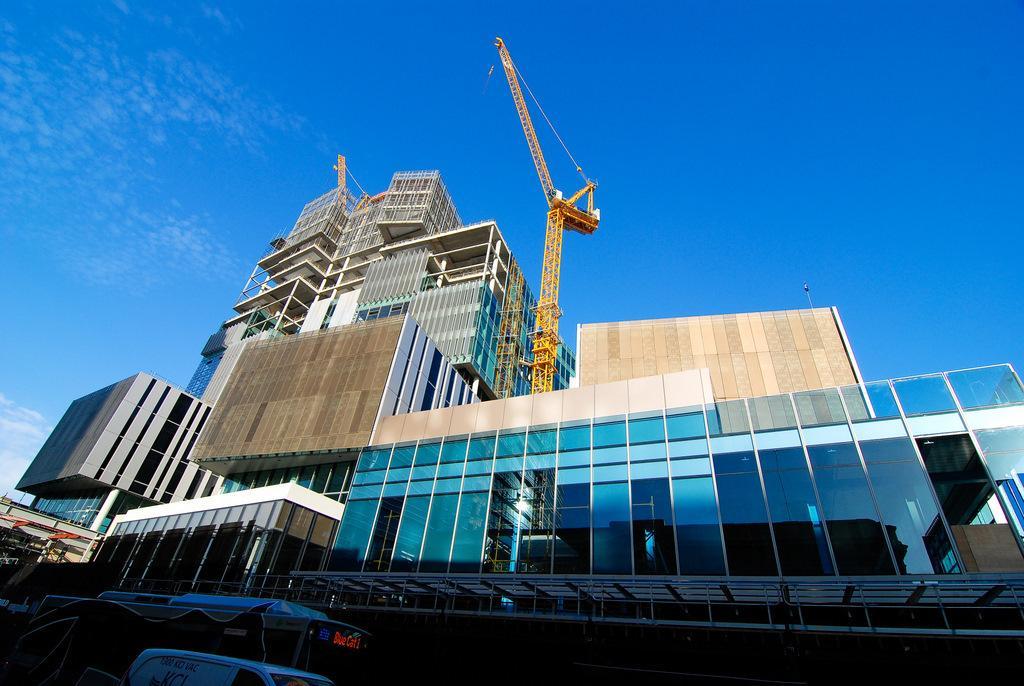In one or two sentences, can you explain what this image depicts? In this image we can see a vehicle at the bottom and there are buildings, glasses, cranes and clouds in the sky. 